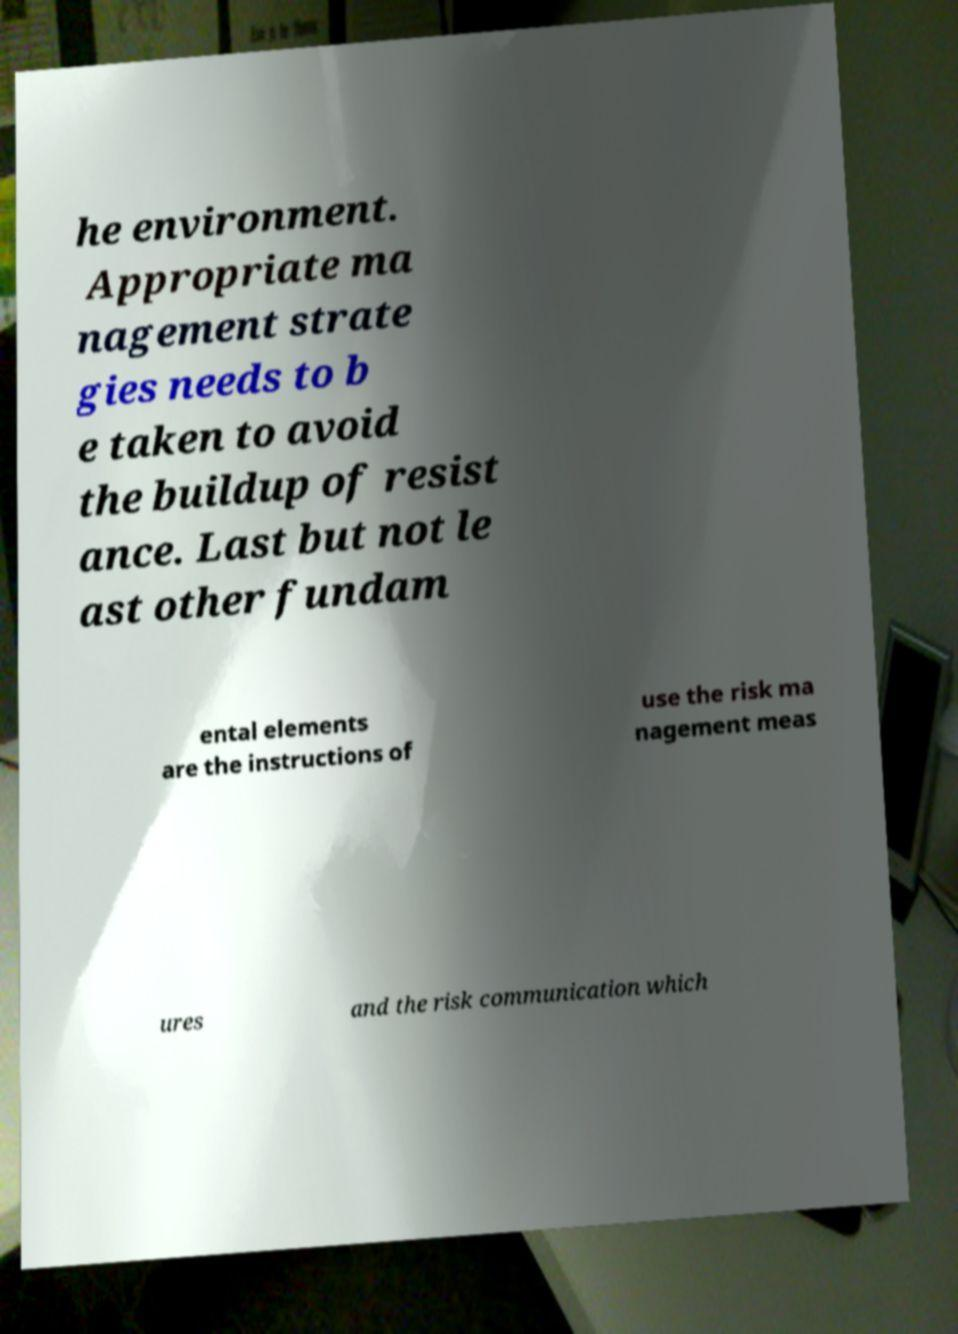Can you read and provide the text displayed in the image?This photo seems to have some interesting text. Can you extract and type it out for me? he environment. Appropriate ma nagement strate gies needs to b e taken to avoid the buildup of resist ance. Last but not le ast other fundam ental elements are the instructions of use the risk ma nagement meas ures and the risk communication which 